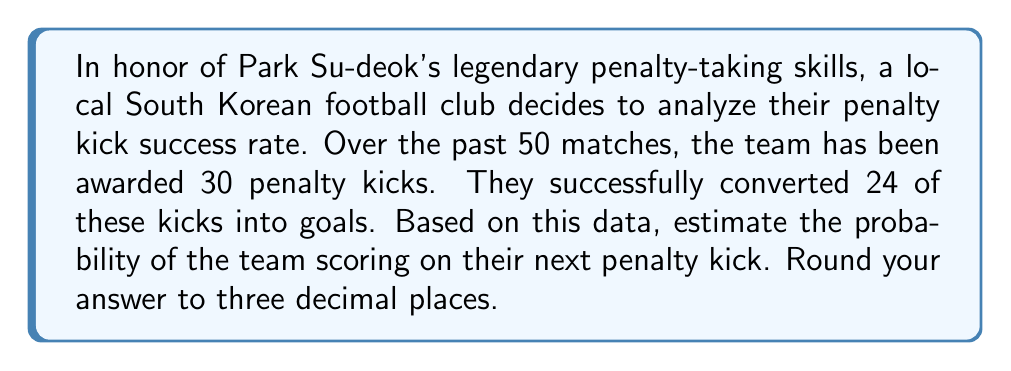Show me your answer to this math problem. To estimate the probability of a successful penalty kick based on historical data, we'll use the concept of relative frequency as an approximation of probability.

Step 1: Identify the relevant data
- Total number of penalty kicks: 30
- Number of successful penalty kicks: 24

Step 2: Calculate the relative frequency
The relative frequency is given by the formula:

$$ P(\text{success}) = \frac{\text{number of successful outcomes}}{\text{total number of trials}} $$

Step 3: Substitute the values
$$ P(\text{success}) = \frac{24}{30} $$

Step 4: Perform the division
$$ P(\text{success}) = 0.8 $$

Step 5: Round to three decimal places
$$ P(\text{success}) \approx 0.800 $$

Therefore, based on the historical data, we estimate that the probability of the team scoring on their next penalty kick is 0.800 or 80.0%.
Answer: 0.800 